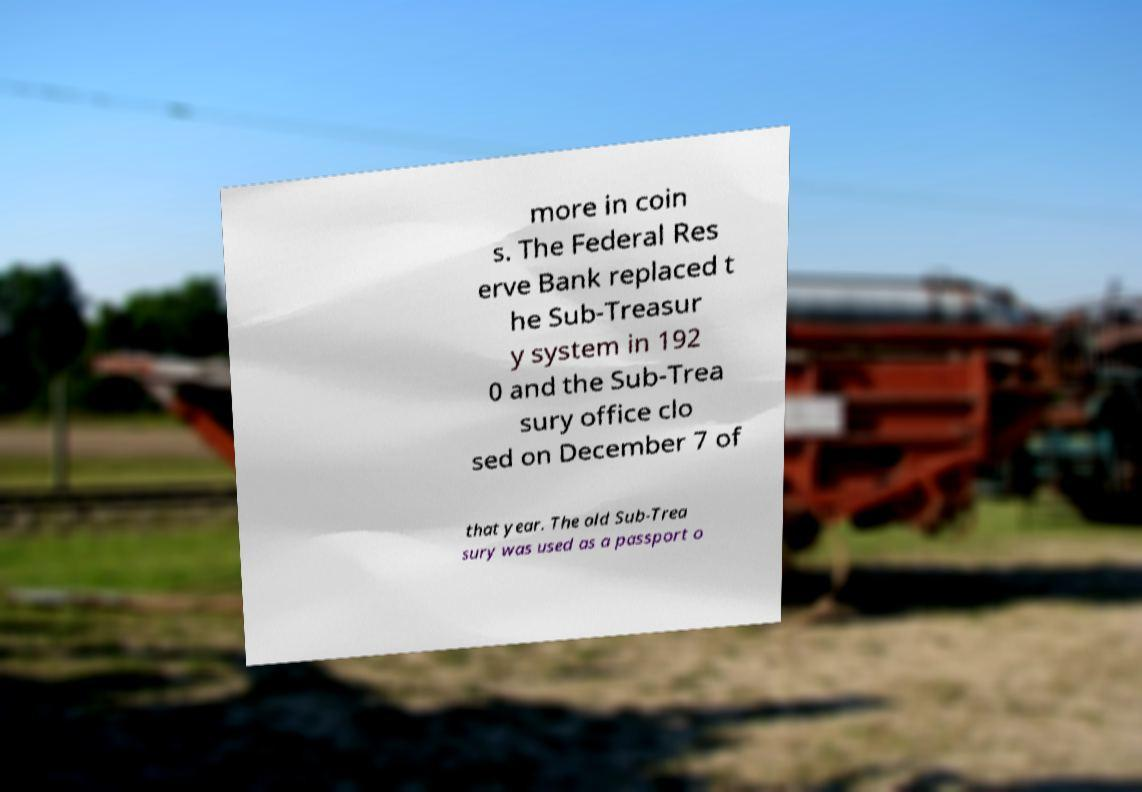There's text embedded in this image that I need extracted. Can you transcribe it verbatim? more in coin s. The Federal Res erve Bank replaced t he Sub-Treasur y system in 192 0 and the Sub-Trea sury office clo sed on December 7 of that year. The old Sub-Trea sury was used as a passport o 